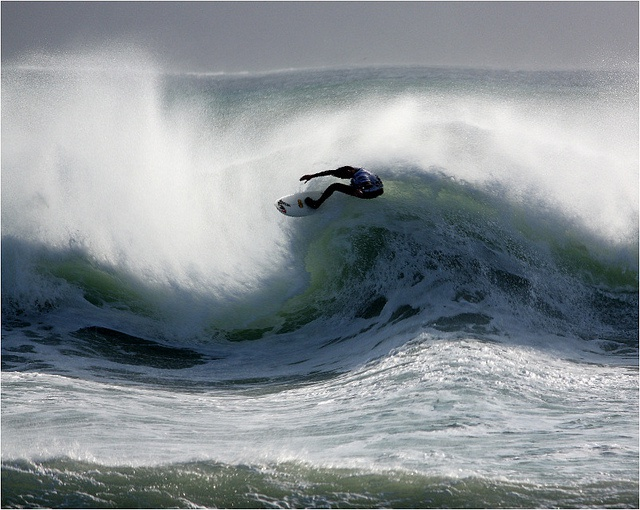Describe the objects in this image and their specific colors. I can see people in white, black, navy, gray, and darkgray tones and surfboard in white, purple, gray, black, and darkgray tones in this image. 